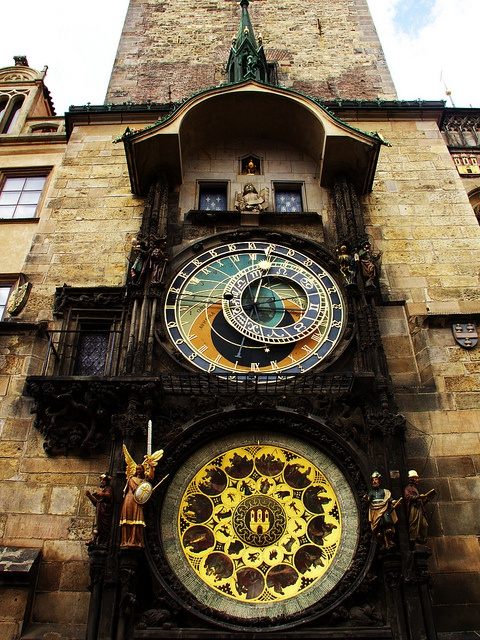Describe the objects in this image and their specific colors. I can see a clock in white, black, beige, gray, and khaki tones in this image. 